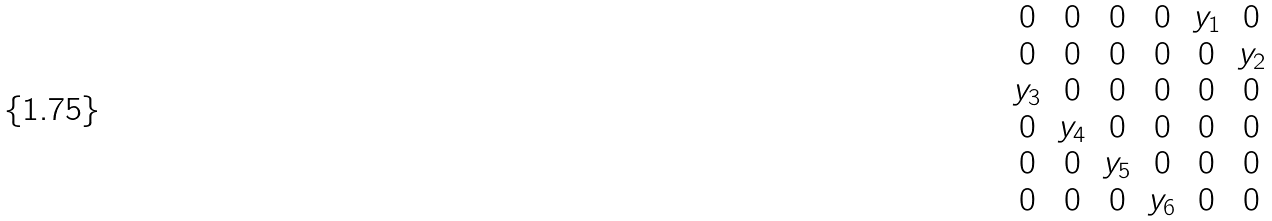Convert formula to latex. <formula><loc_0><loc_0><loc_500><loc_500>\begin{matrix} 0 & 0 & 0 & 0 & y _ { 1 } & 0 \\ 0 & 0 & 0 & 0 & 0 & y _ { 2 } \\ y _ { 3 } & 0 & 0 & 0 & 0 & 0 \\ 0 & y _ { 4 } & 0 & 0 & 0 & 0 \\ 0 & 0 & y _ { 5 } & 0 & 0 & 0 \\ 0 & 0 & 0 & y _ { 6 } & 0 & 0 \end{matrix}</formula> 